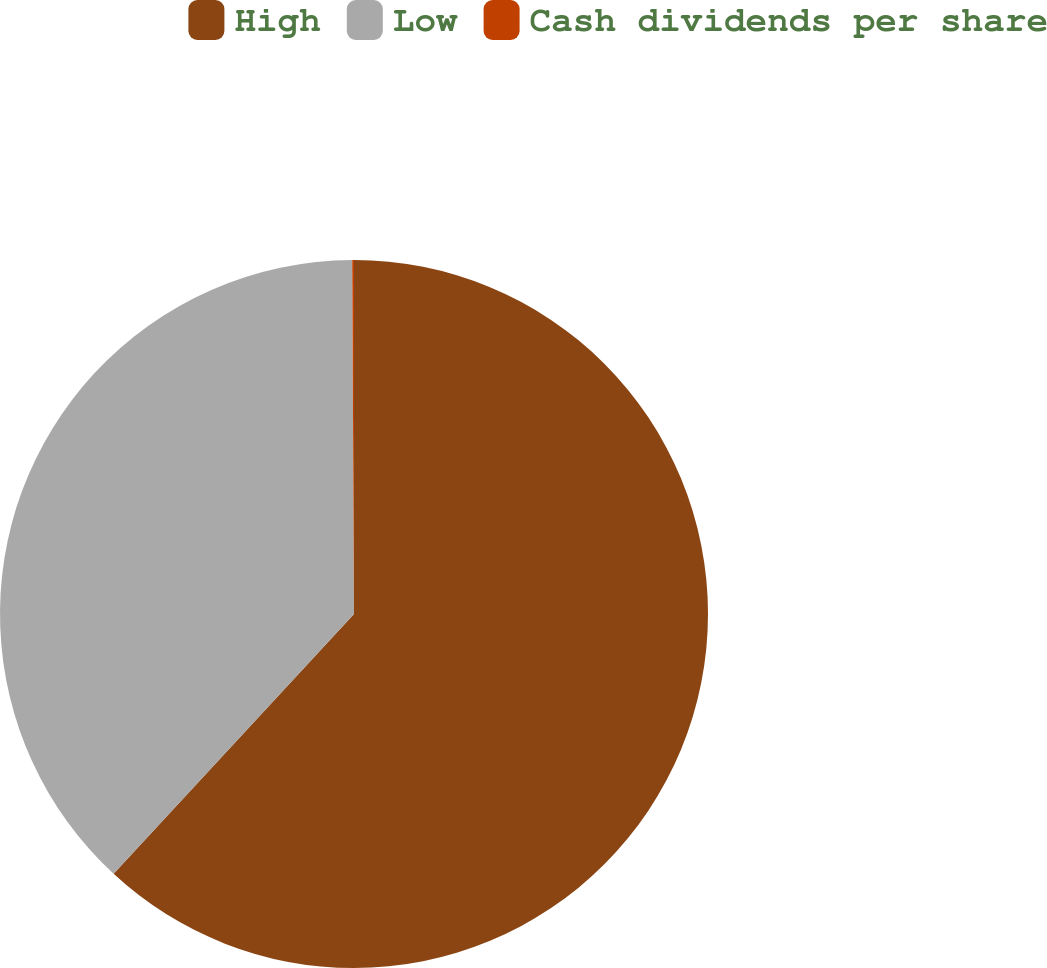Convert chart to OTSL. <chart><loc_0><loc_0><loc_500><loc_500><pie_chart><fcel>High<fcel>Low<fcel>Cash dividends per share<nl><fcel>61.88%<fcel>38.04%<fcel>0.08%<nl></chart> 